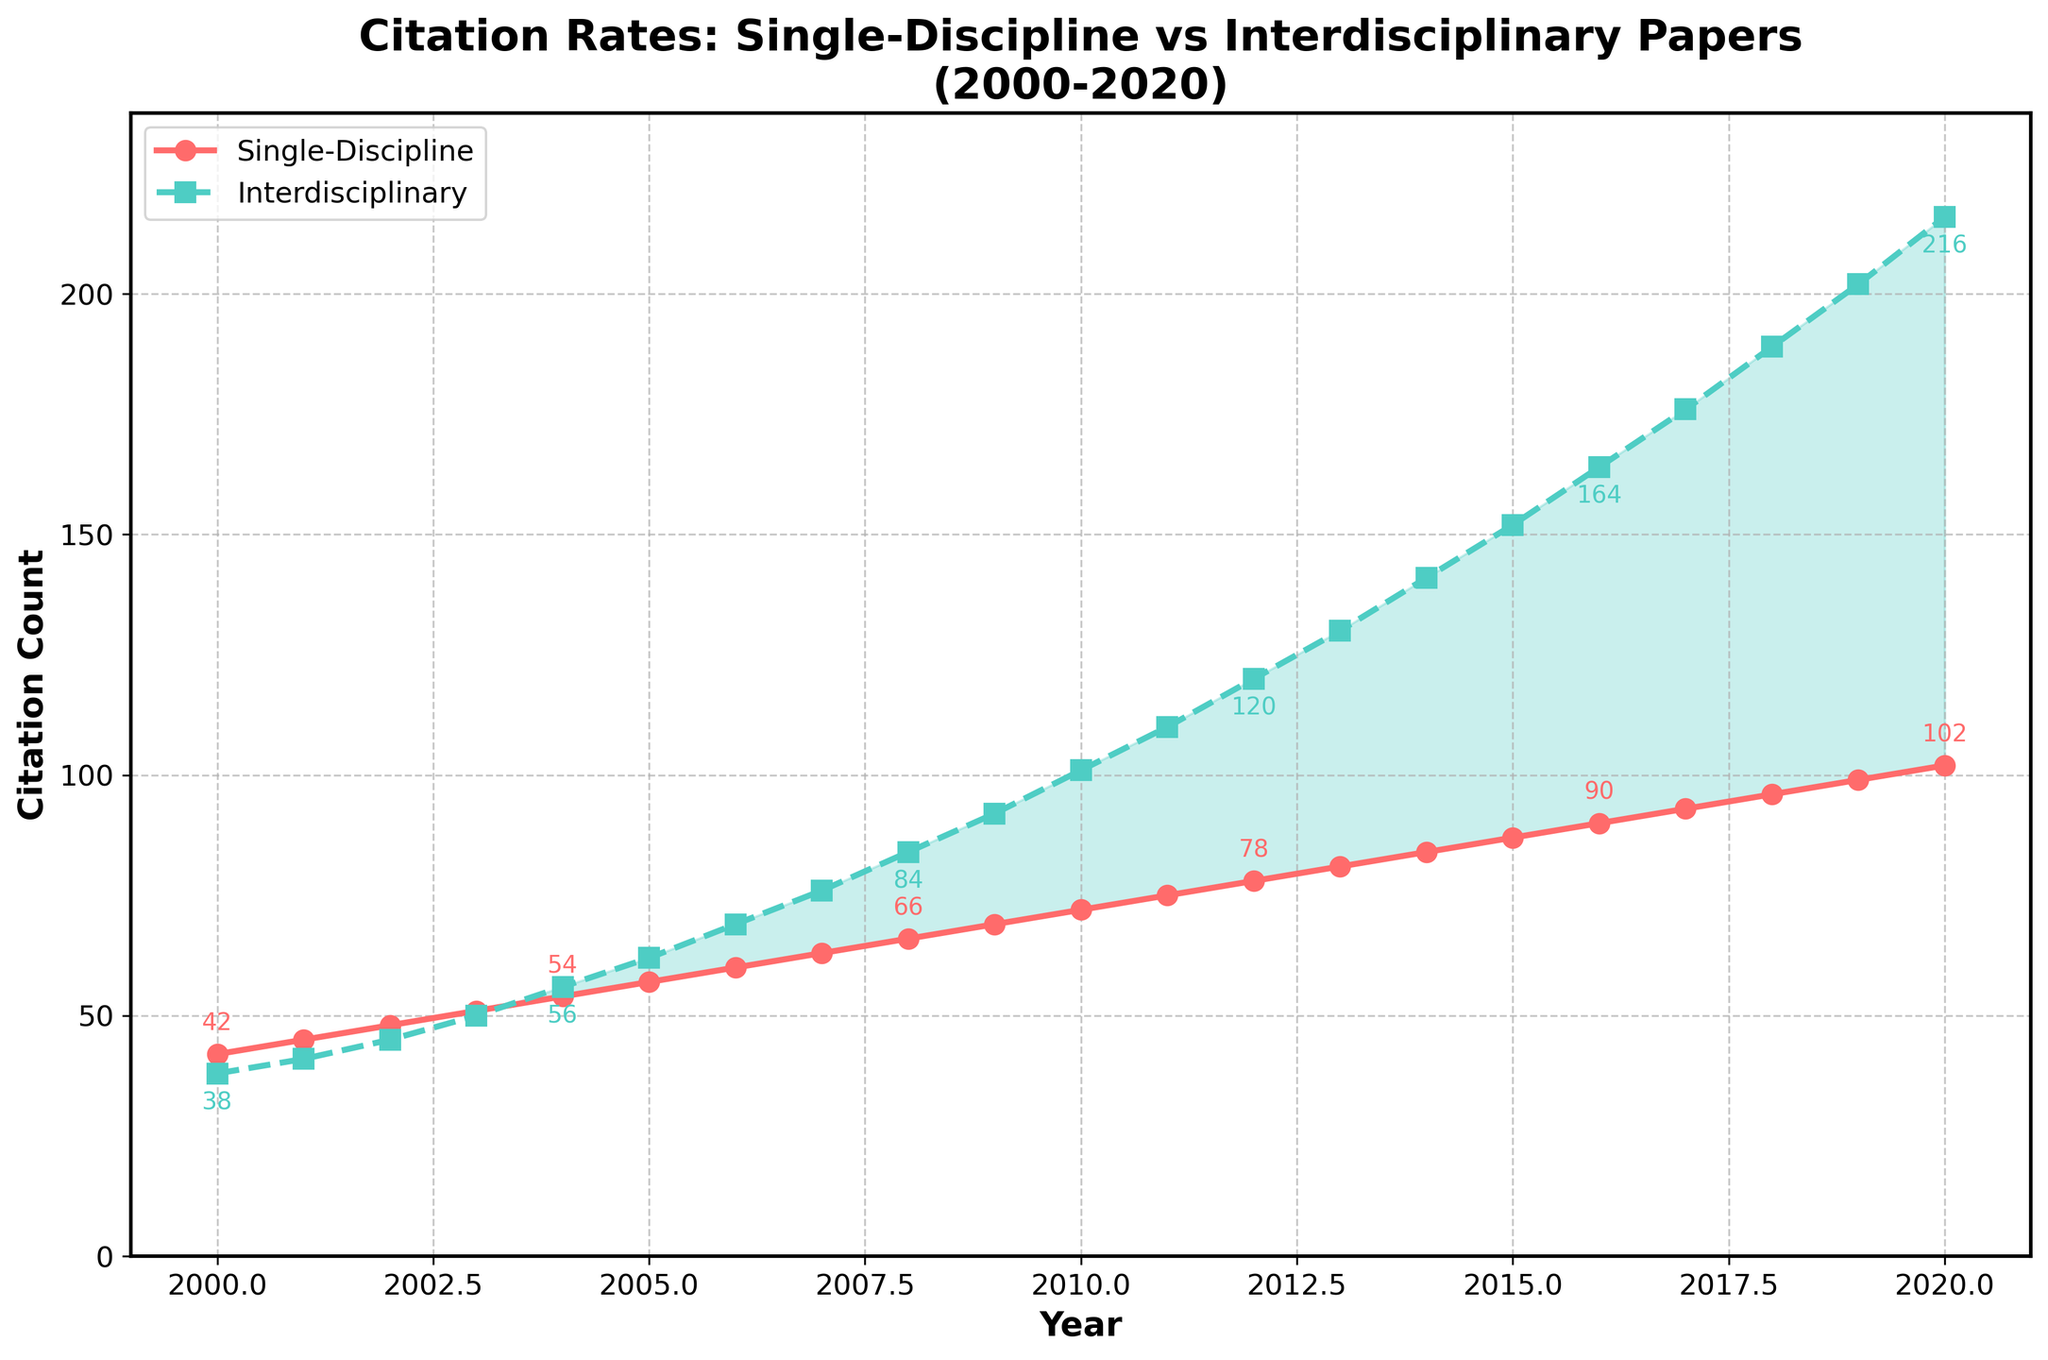What is the general trend for citation rates of both single-discipline and interdisciplinary papers from 2000 to 2020? Both single-discipline and interdisciplinary citation rates show an increasing trend. Citation rates for interdisciplinary papers grow at a faster rate compared to single-discipline papers.
Answer: Increasing In which year do the citation rates of interdisciplinary papers surpass those of single-discipline papers? By observing the intersection point where the green dashed line (interdisciplinary) is above the red solid line (single-discipline), we see that this occurs around 2004.
Answer: 2004 How much had the citation count for interdisciplinary papers increased from 2000 to 2010? Interdisciplinary citations in 2000 were 38 and in 2010 they were 101. Subtracting the initial value from the final value, 101 - 38 = 63.
Answer: 63 What is the difference in citation counts between interdisciplinary and single-discipline papers in 2020? The citation count for single-discipline papers in 2020 is 102, and for interdisciplinary papers, it's 216. The difference is 216 - 102 = 114.
Answer: 114 In which year does the citation rate of single-discipline papers firstly reach at least 70? Checking the red solid line (single-discipline), the citation rate reaches at least 70 in 2009.
Answer: 2009 What visual attribute helps in distinguishing between single-discipline and interdisciplinary citation trends? The single-discipline line is continuous and red with circle markers while the interdisciplinary line is dashed and green with square markers.
Answer: Line style and color By how much did the citation count of single-discipline papers increase from 2002 to 2012? Checking the citation count for 2002 (48) and 2012 (78), the increase is 78 - 48 = 30.
Answer: 30 What were the citation counts for both types of papers in 2015, and how do they compare? In 2015, single-discipline papers had 87 citations, and interdisciplinary papers had 152 citations. Interdisciplinary papers had significantly more citations by 152 - 87 = 65.
Answer: 87, 152; more by 65 Does the gap between citation counts of single-discipline and interdisciplinary papers widen or narrow over the years? The gap widens, as the difference between citation counts becomes larger from 2000 to 2020.
Answer: Widens What annotate feature gives you numeric hints in the figure? Annotation numbers appear above the points for single-discipline and below the points for interdisciplinary, with step intervals.
Answer: Numerical annotations 